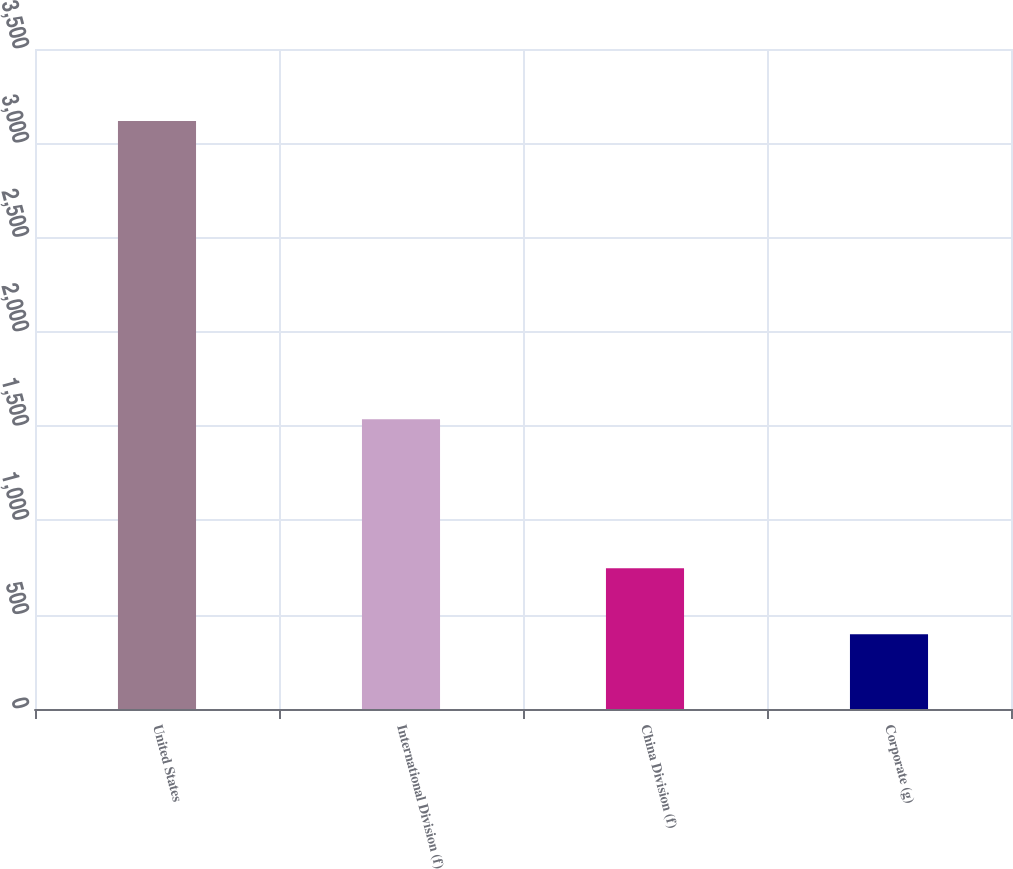<chart> <loc_0><loc_0><loc_500><loc_500><bar_chart><fcel>United States<fcel>International Division (f)<fcel>China Division (f)<fcel>Corporate (g)<nl><fcel>3118<fcel>1536<fcel>746<fcel>397<nl></chart> 